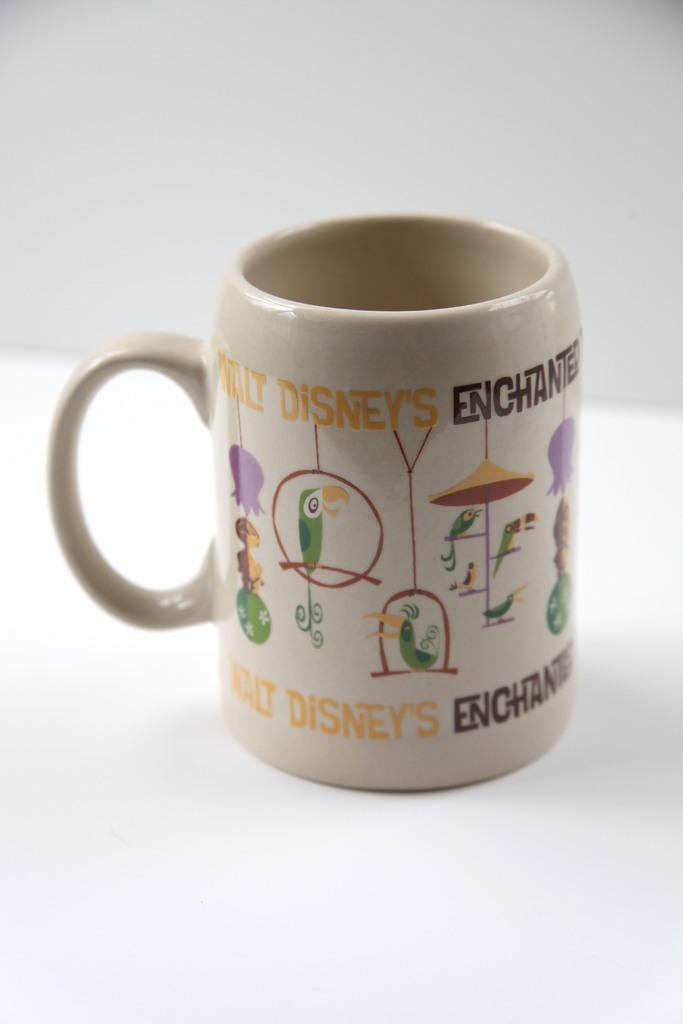What is mr. disney's first name?
Provide a short and direct response. Walt. What company logo is being mentioned on the coffee mug?
Offer a terse response. Disney. 